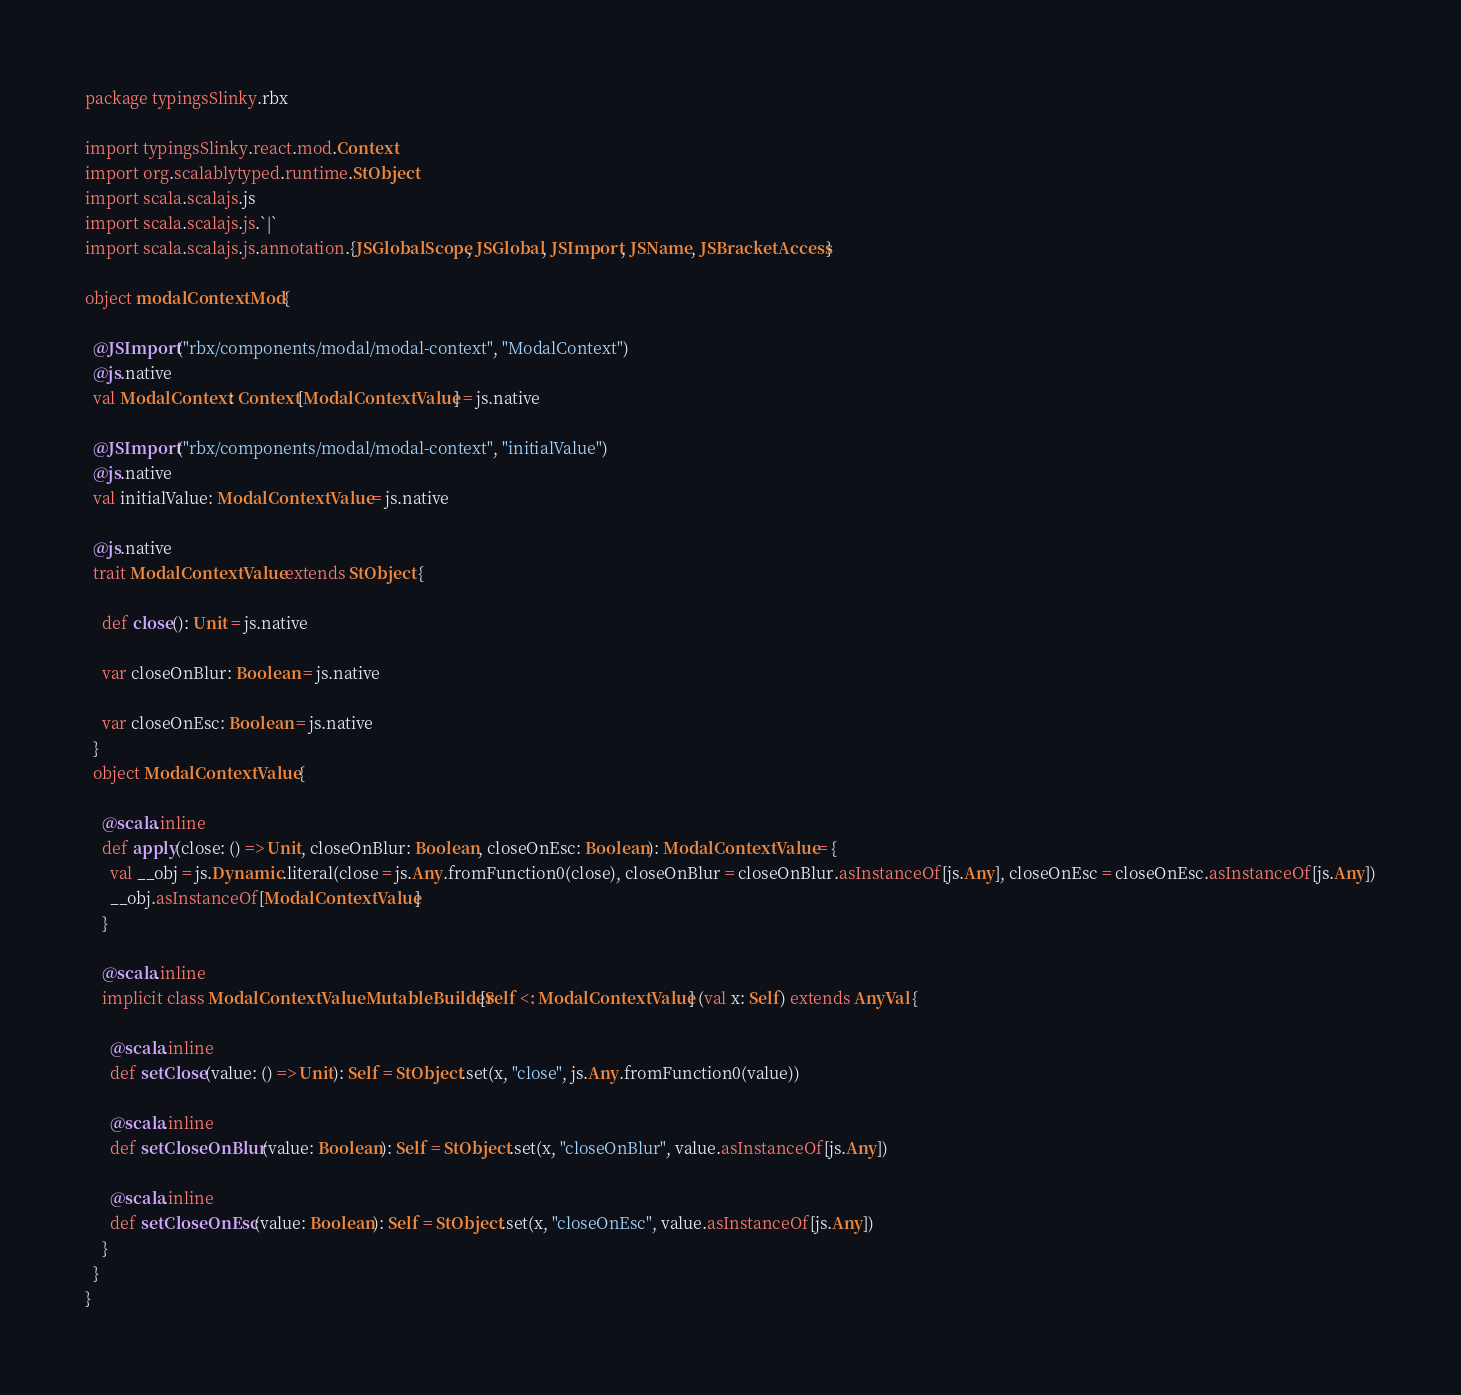Convert code to text. <code><loc_0><loc_0><loc_500><loc_500><_Scala_>package typingsSlinky.rbx

import typingsSlinky.react.mod.Context
import org.scalablytyped.runtime.StObject
import scala.scalajs.js
import scala.scalajs.js.`|`
import scala.scalajs.js.annotation.{JSGlobalScope, JSGlobal, JSImport, JSName, JSBracketAccess}

object modalContextMod {
  
  @JSImport("rbx/components/modal/modal-context", "ModalContext")
  @js.native
  val ModalContext: Context[ModalContextValue] = js.native
  
  @JSImport("rbx/components/modal/modal-context", "initialValue")
  @js.native
  val initialValue: ModalContextValue = js.native
  
  @js.native
  trait ModalContextValue extends StObject {
    
    def close(): Unit = js.native
    
    var closeOnBlur: Boolean = js.native
    
    var closeOnEsc: Boolean = js.native
  }
  object ModalContextValue {
    
    @scala.inline
    def apply(close: () => Unit, closeOnBlur: Boolean, closeOnEsc: Boolean): ModalContextValue = {
      val __obj = js.Dynamic.literal(close = js.Any.fromFunction0(close), closeOnBlur = closeOnBlur.asInstanceOf[js.Any], closeOnEsc = closeOnEsc.asInstanceOf[js.Any])
      __obj.asInstanceOf[ModalContextValue]
    }
    
    @scala.inline
    implicit class ModalContextValueMutableBuilder[Self <: ModalContextValue] (val x: Self) extends AnyVal {
      
      @scala.inline
      def setClose(value: () => Unit): Self = StObject.set(x, "close", js.Any.fromFunction0(value))
      
      @scala.inline
      def setCloseOnBlur(value: Boolean): Self = StObject.set(x, "closeOnBlur", value.asInstanceOf[js.Any])
      
      @scala.inline
      def setCloseOnEsc(value: Boolean): Self = StObject.set(x, "closeOnEsc", value.asInstanceOf[js.Any])
    }
  }
}
</code> 